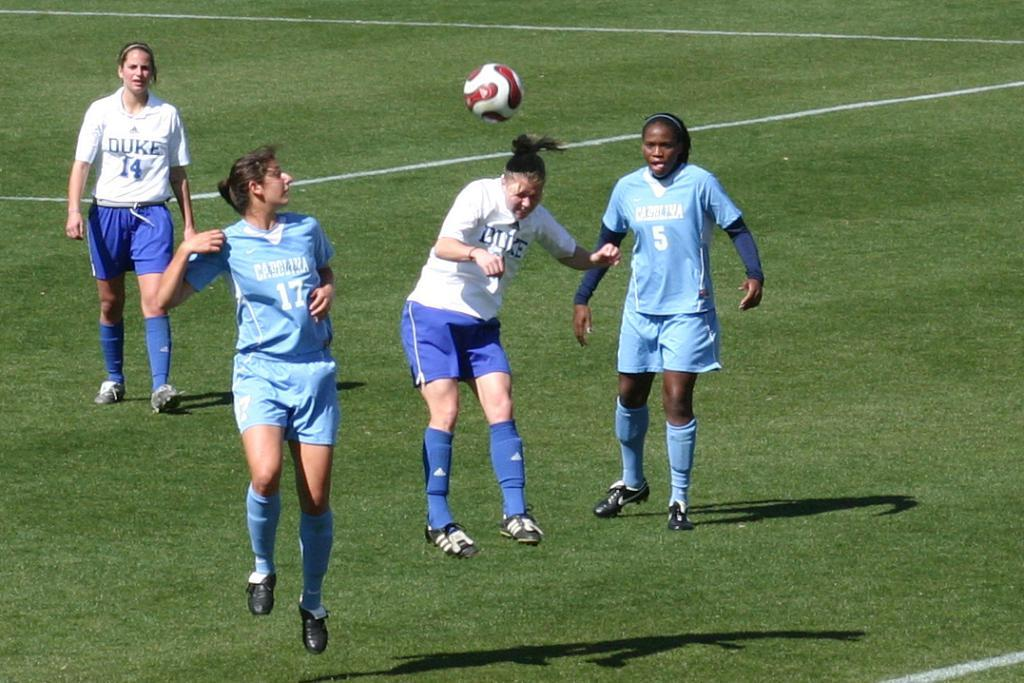Who or what is present in the image? There are people in the image. What are the people wearing? The people are wearing blue and white color dresses. What else can be seen in the image? There is a ball in the image. Where are the people and the ball located? The people and the ball are on the ground. What type of addition problem can be solved using the numbers on the stage in the image? There is no stage present in the image, and therefore no addition problem can be solved using numbers from it. 